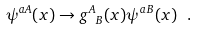Convert formula to latex. <formula><loc_0><loc_0><loc_500><loc_500>\psi ^ { a A } ( x ) \rightarrow { g ^ { A } } _ { B } ( x ) \psi ^ { a B } ( x ) \ .</formula> 